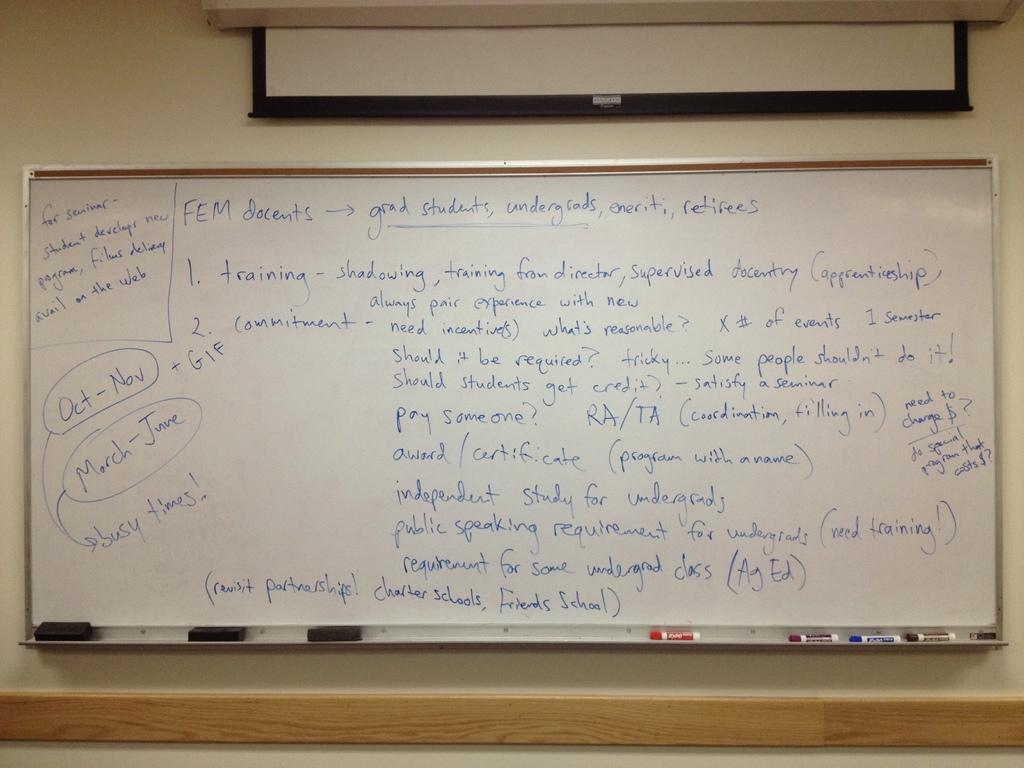What is the main object in the image? There is a white color board in the image. What is located next to the color board? There is a projector's screen in the image. What tools are present for cleaning or maintaining the board? Dusters are present in the image for cleaning or maintaining the board. What items are available for writing on the board? Markers are present in the image for writing on the board. What can be seen written on the board? Something is written on the board in the image. What type of soup is being served on the board in the image? There is no soup present in the image; it features a white color board with a projector's screen, dusters, markers, and something written on the board. 